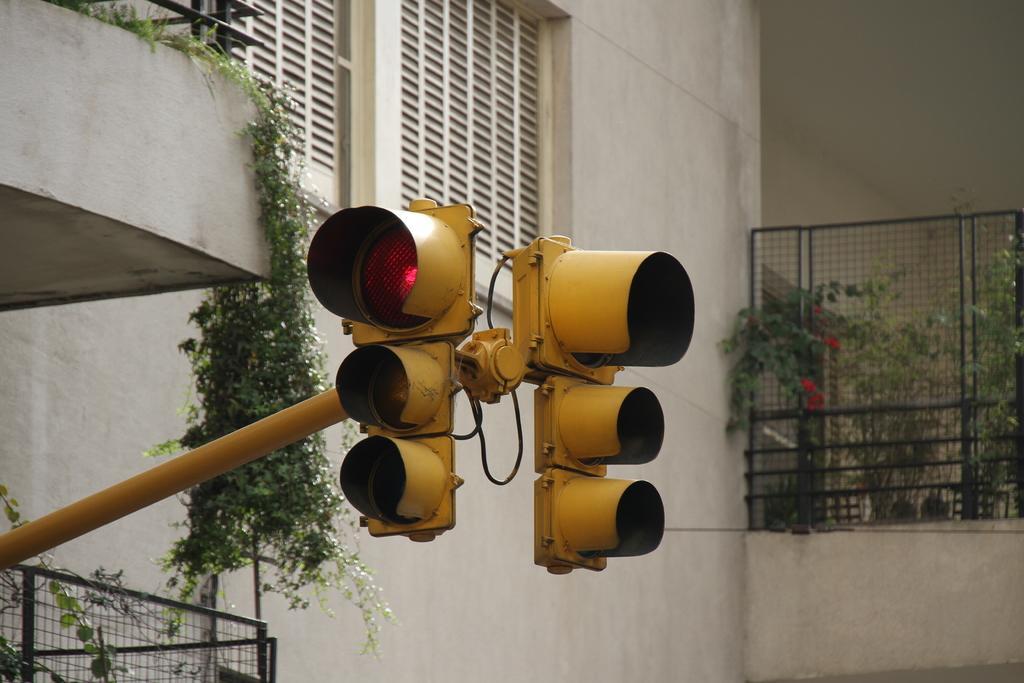Describe this image in one or two sentences. In this image in the front there are traffic signals. In the background there are plants and there is a fence. On the left side there are plants and there is a grill and there are windows. 